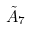Convert formula to latex. <formula><loc_0><loc_0><loc_500><loc_500>\tilde { A } _ { 7 }</formula> 